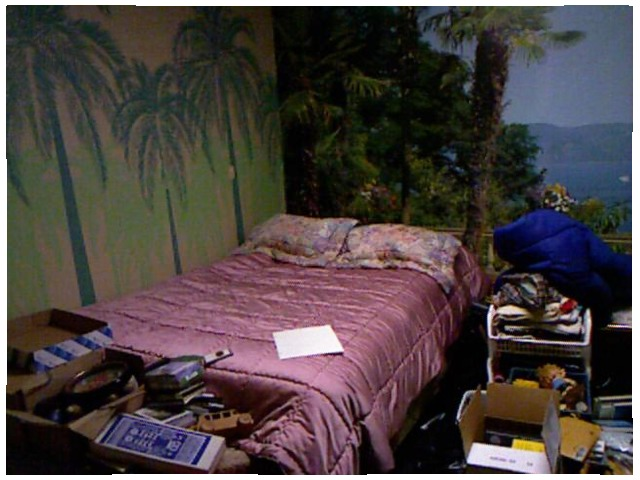<image>
Is there a paper in front of the bed? No. The paper is not in front of the bed. The spatial positioning shows a different relationship between these objects. Is there a tree on the wall? Yes. Looking at the image, I can see the tree is positioned on top of the wall, with the wall providing support. Where is the paper in relation to the bed? Is it on the bed? Yes. Looking at the image, I can see the paper is positioned on top of the bed, with the bed providing support. Is there a blanket under the paper? Yes. The blanket is positioned underneath the paper, with the paper above it in the vertical space. Is there a box under the bed? No. The box is not positioned under the bed. The vertical relationship between these objects is different. 